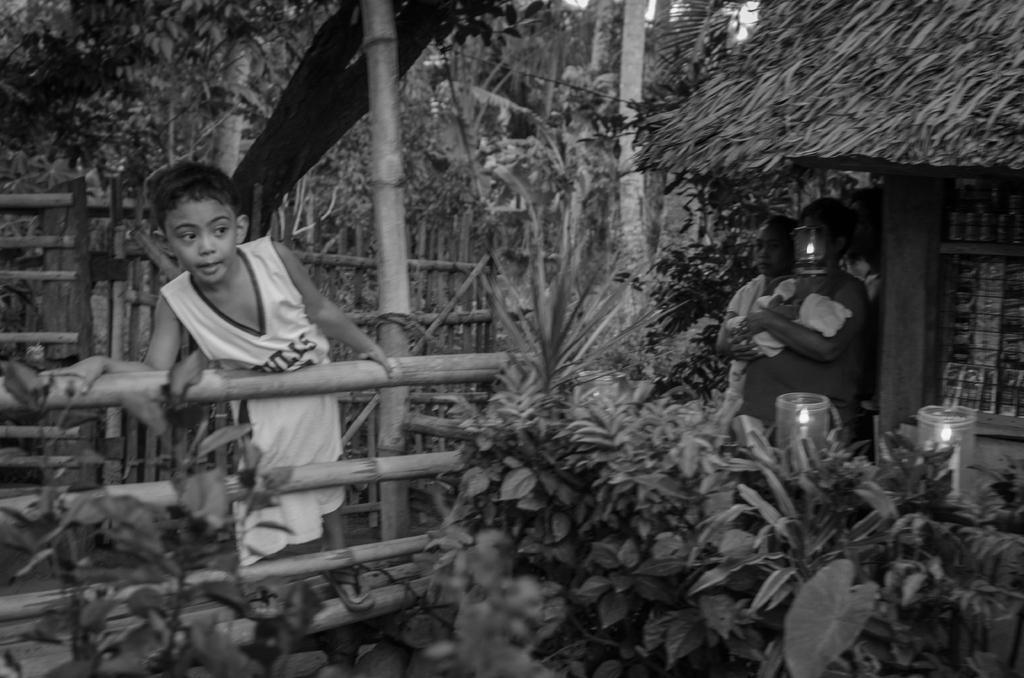Could you give a brief overview of what you see in this image? In this picture there is a boy standing on the wooden railing. On the right side of the image there is a person standing and holding the baby and there is a person standing and there is a light lamp hanging and there are candles. On the right side of the image there is a hut. At the back there is a wooden railing and there are trees. 